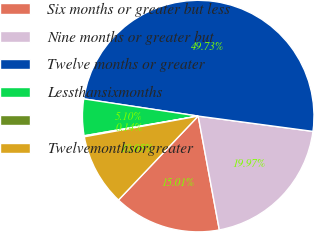Convert chart. <chart><loc_0><loc_0><loc_500><loc_500><pie_chart><fcel>Six months or greater but less<fcel>Nine months or greater but<fcel>Twelve months or greater<fcel>Lessthansixmonths<fcel>Unnamed: 4<fcel>Twelvemonthsorgreater<nl><fcel>15.01%<fcel>19.97%<fcel>49.73%<fcel>5.1%<fcel>0.14%<fcel>10.05%<nl></chart> 